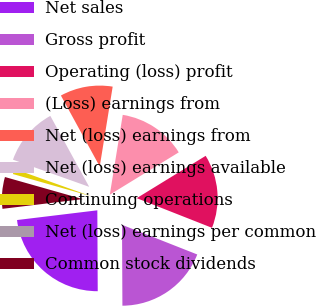<chart> <loc_0><loc_0><loc_500><loc_500><pie_chart><fcel>Net sales<fcel>Gross profit<fcel>Operating (loss) profit<fcel>(Loss) earnings from<fcel>Net (loss) earnings from<fcel>Net (loss) earnings available<fcel>Continuing operations<fcel>Net (loss) earnings per common<fcel>Common stock dividends<nl><fcel>23.16%<fcel>18.95%<fcel>14.74%<fcel>13.68%<fcel>10.53%<fcel>11.58%<fcel>1.05%<fcel>0.0%<fcel>6.32%<nl></chart> 